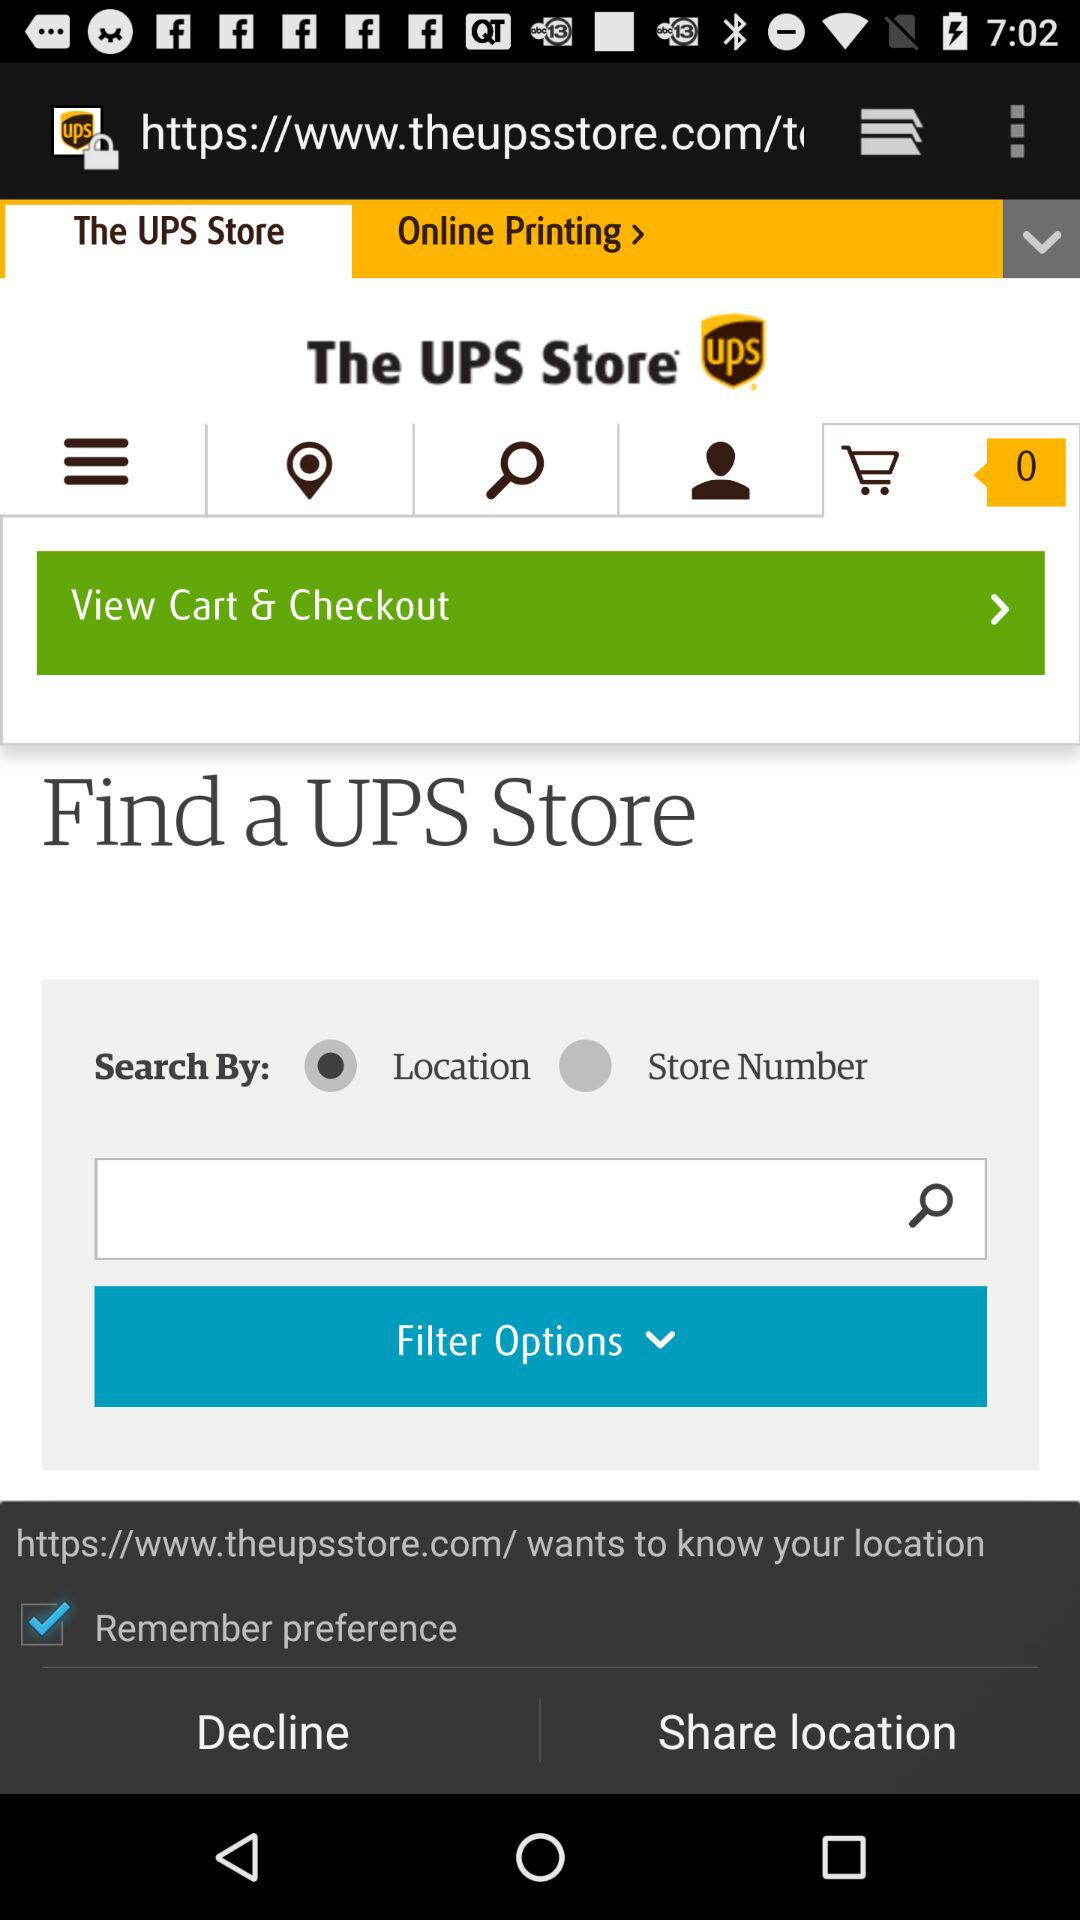What is the application name? The application name is "The UPS Store". 